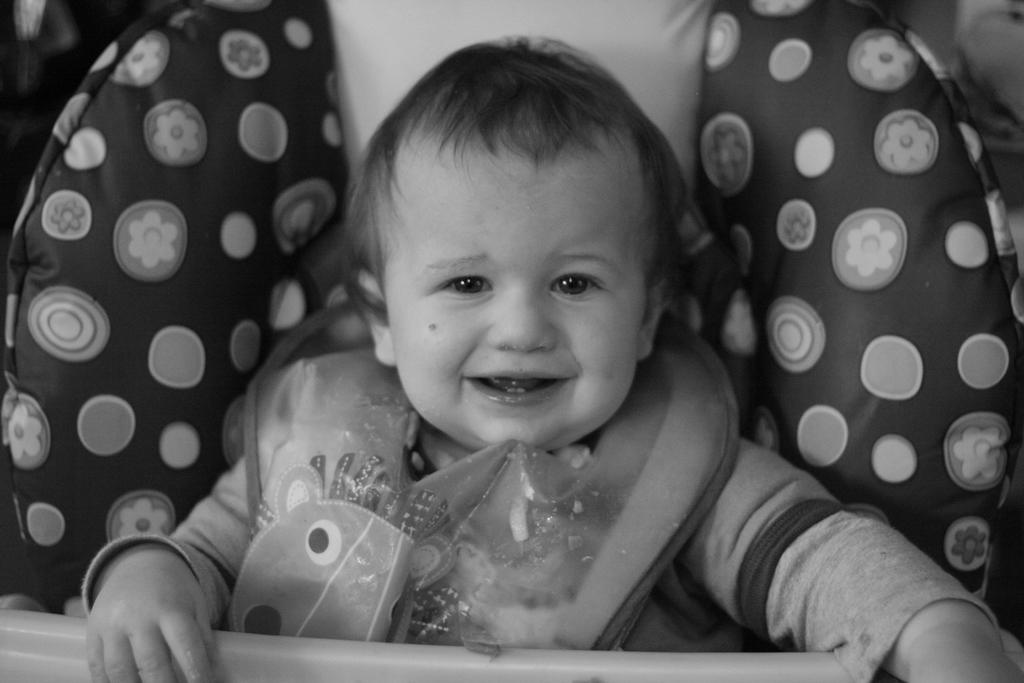What is the color scheme of the image? The image is black and white. What is the main subject of the image? There is a baby in the image. What is the baby doing in the image? The baby is sitting in a baby chair and smiling. What type of pie is the baby holding in the image? There is no pie present in the image; the baby is sitting in a baby chair and smiling. 